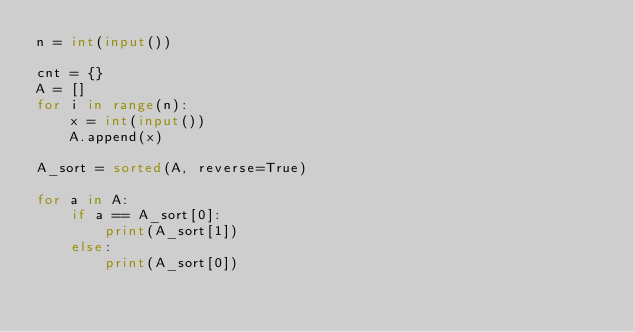<code> <loc_0><loc_0><loc_500><loc_500><_Python_>n = int(input())

cnt = {}
A = []
for i in range(n):
    x = int(input())
    A.append(x)

A_sort = sorted(A, reverse=True)

for a in A:
    if a == A_sort[0]:
        print(A_sort[1])
    else:
        print(A_sort[0])
        </code> 